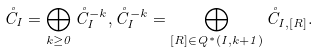Convert formula to latex. <formula><loc_0><loc_0><loc_500><loc_500>\mathring { C } _ { I } = \bigoplus _ { k \geq 0 } \mathring { C } _ { I } ^ { - k } , \mathring { C } _ { I } ^ { - k } = \bigoplus _ { [ R ] \in Q ^ { * } ( I , k + 1 ) } \mathring { C } _ { I , [ R ] } .</formula> 